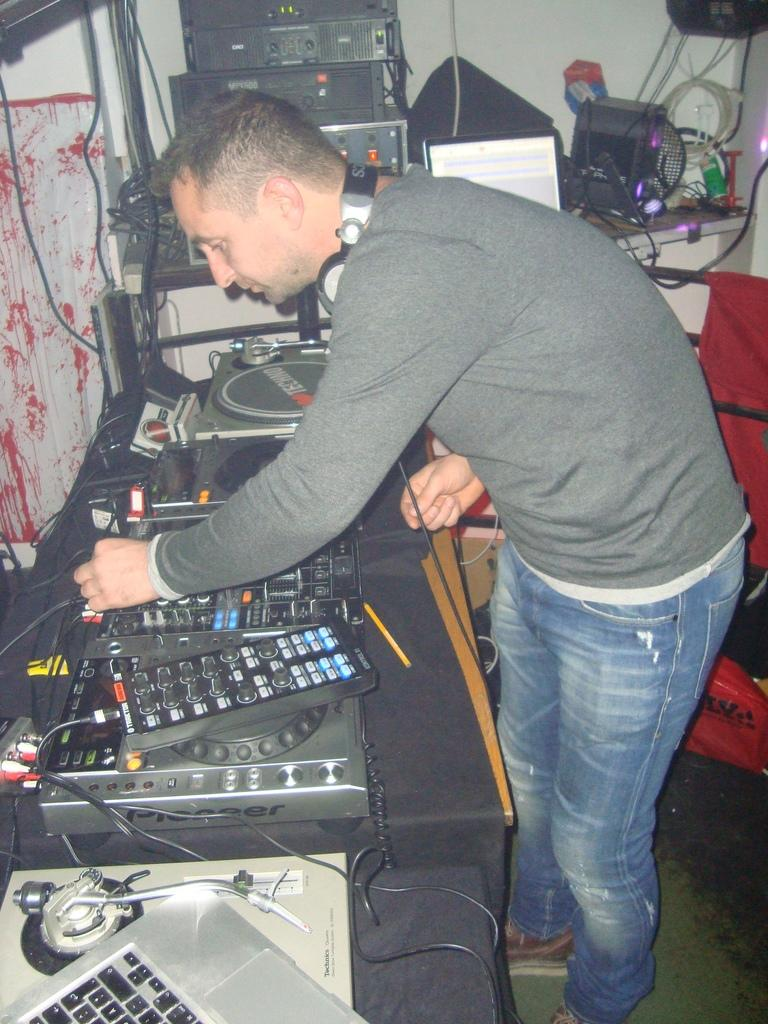What is the main subject of the image? There is a man standing in the image. What can be seen on the tables in the image? There are electronic items on a table, and there is a laptop on another table. What device is visible in the image that is typically used for audio communication? A headset is visible in the image. What is the man in the image doing? The man is connecting wires. What type of honey is the man using to connect the wires in the image? There is no honey present in the image, and the man is connecting wires using electronic components, not honey. 